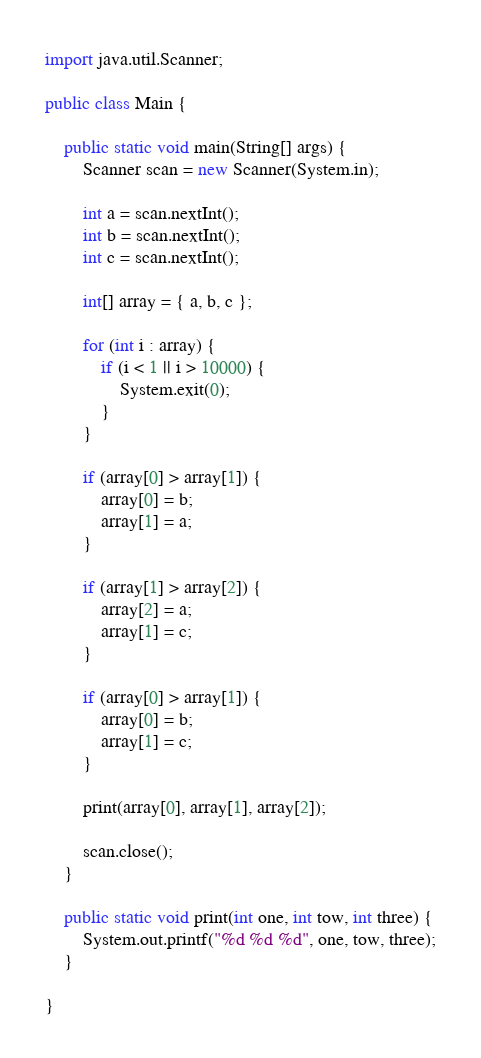Convert code to text. <code><loc_0><loc_0><loc_500><loc_500><_Java_>import java.util.Scanner;

public class Main {

    public static void main(String[] args) {
        Scanner scan = new Scanner(System.in);

        int a = scan.nextInt();
        int b = scan.nextInt();
        int c = scan.nextInt();

        int[] array = { a, b, c };

        for (int i : array) {
            if (i < 1 || i > 10000) {
                System.exit(0);
            }
        }

        if (array[0] > array[1]) {
            array[0] = b;
            array[1] = a;
        }

        if (array[1] > array[2]) {
            array[2] = a;
            array[1] = c;
        }

        if (array[0] > array[1]) {
            array[0] = b;
            array[1] = c;
        }

        print(array[0], array[1], array[2]);

        scan.close();
    }

    public static void print(int one, int tow, int three) {
        System.out.printf("%d %d %d", one, tow, three);
    }

}

</code> 